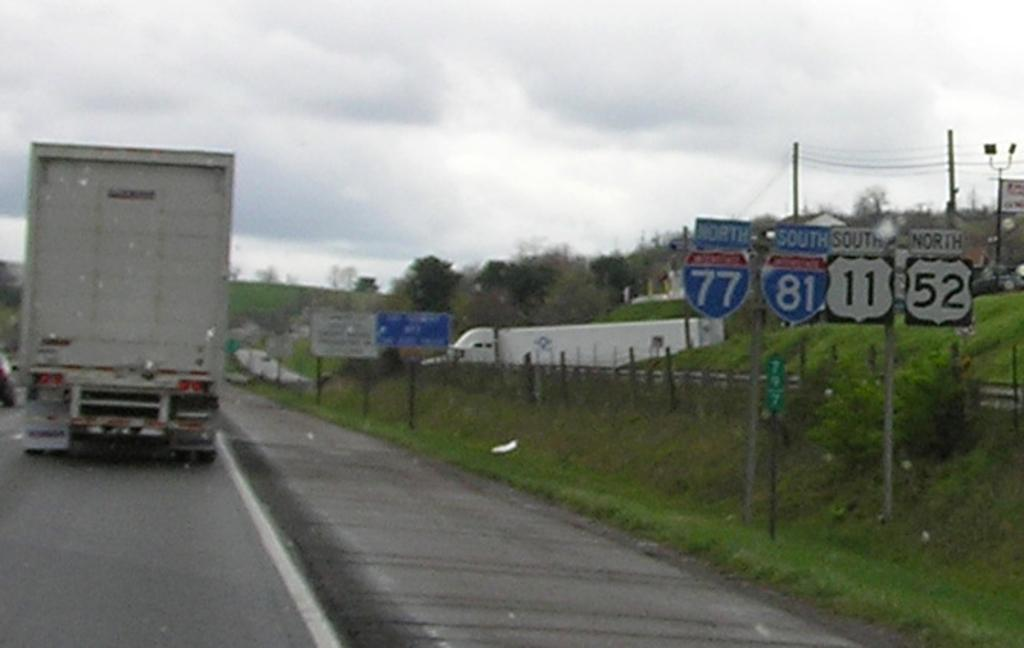What is on the road in the image? There is a vehicle on the road in the image. What can be seen near the road in the image? There is a fence in the image. What type of vegetation is present in the image? Grass, plants, and trees are visible in the image. What are the poles with wires used for in the image? The poles with wires are likely used for electrical or communication purposes. What is visible in the background of the image? The sky is visible in the background of the image. What type of lipstick is being applied to the patch in the image? There is no lipstick or patch present in the image. 